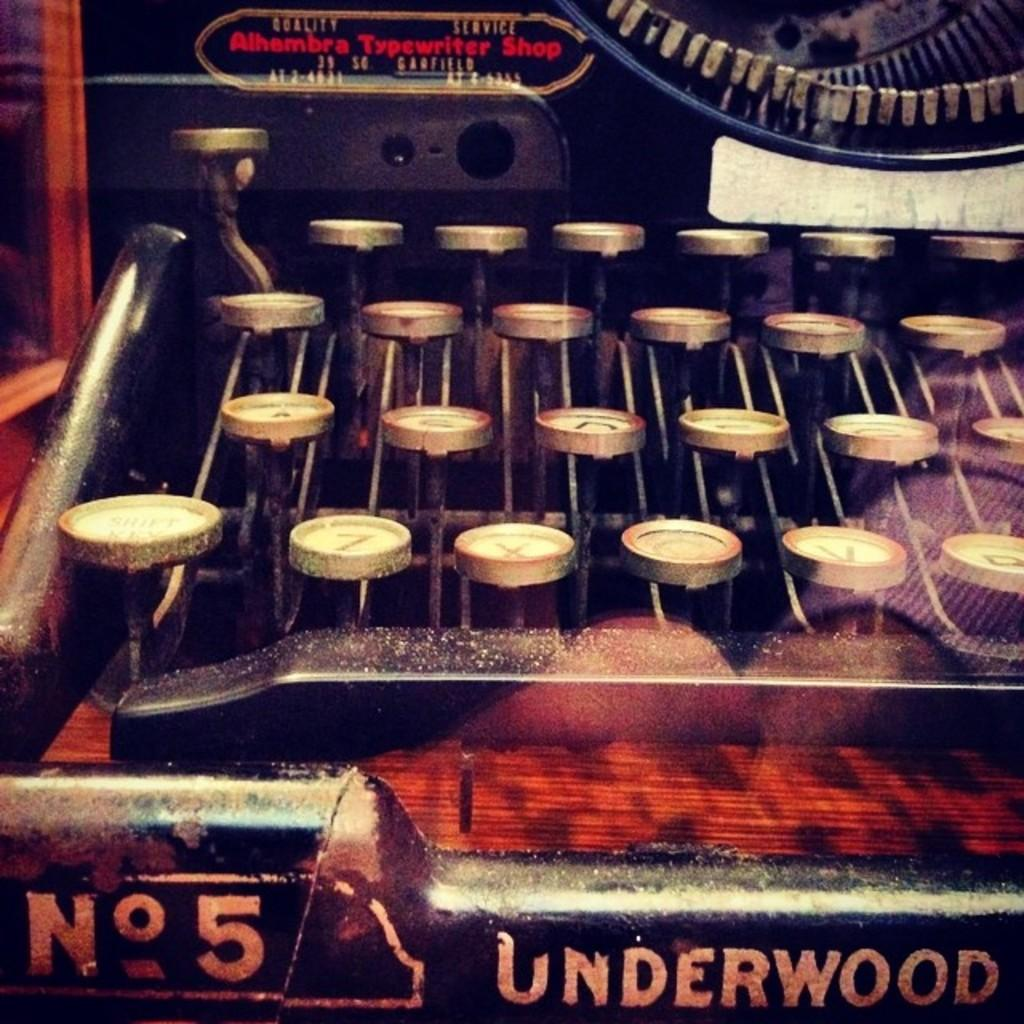What is the main object in the image? There is a typewriter in the image. What is the purpose of the typewriter? The typewriter is used for typing and writing. Is there any text or writing visible on the typewriter? Yes, something is written on the typewriter. How many birds are sitting on the sack in the image? There is no sack or bird present in the image; it only features a typewriter with something written on it. 